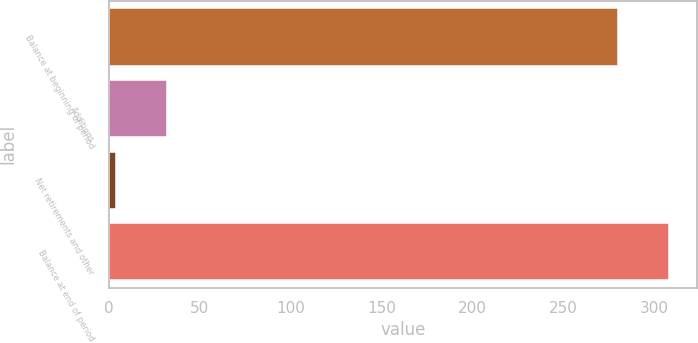Convert chart to OTSL. <chart><loc_0><loc_0><loc_500><loc_500><bar_chart><fcel>Balance at beginning of period<fcel>Additions<fcel>Net retirements and other<fcel>Balance at end of period<nl><fcel>280<fcel>32.1<fcel>4<fcel>308.1<nl></chart> 